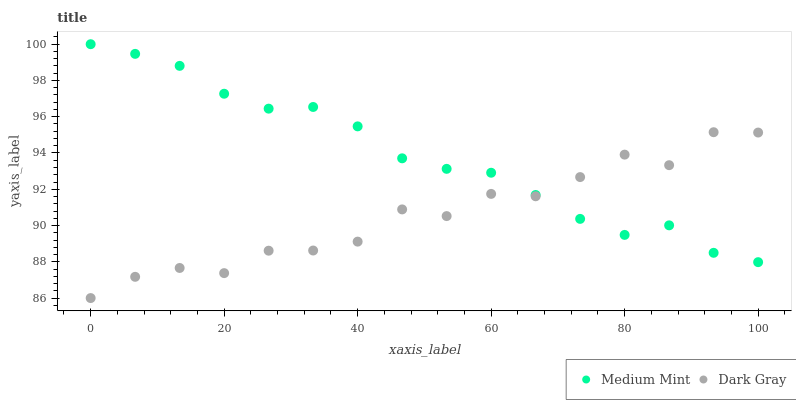Does Dark Gray have the minimum area under the curve?
Answer yes or no. Yes. Does Medium Mint have the maximum area under the curve?
Answer yes or no. Yes. Does Dark Gray have the maximum area under the curve?
Answer yes or no. No. Is Medium Mint the smoothest?
Answer yes or no. Yes. Is Dark Gray the roughest?
Answer yes or no. Yes. Is Dark Gray the smoothest?
Answer yes or no. No. Does Dark Gray have the lowest value?
Answer yes or no. Yes. Does Medium Mint have the highest value?
Answer yes or no. Yes. Does Dark Gray have the highest value?
Answer yes or no. No. Does Dark Gray intersect Medium Mint?
Answer yes or no. Yes. Is Dark Gray less than Medium Mint?
Answer yes or no. No. Is Dark Gray greater than Medium Mint?
Answer yes or no. No. 